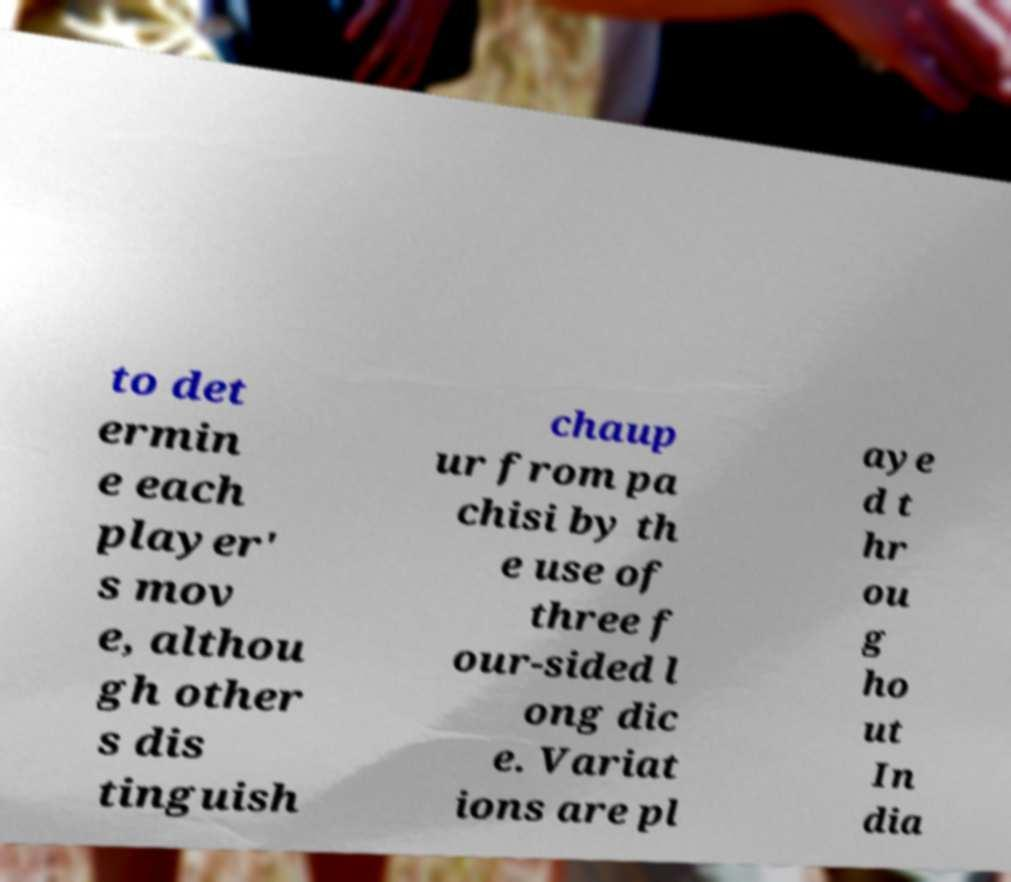Please identify and transcribe the text found in this image. to det ermin e each player' s mov e, althou gh other s dis tinguish chaup ur from pa chisi by th e use of three f our-sided l ong dic e. Variat ions are pl aye d t hr ou g ho ut In dia 